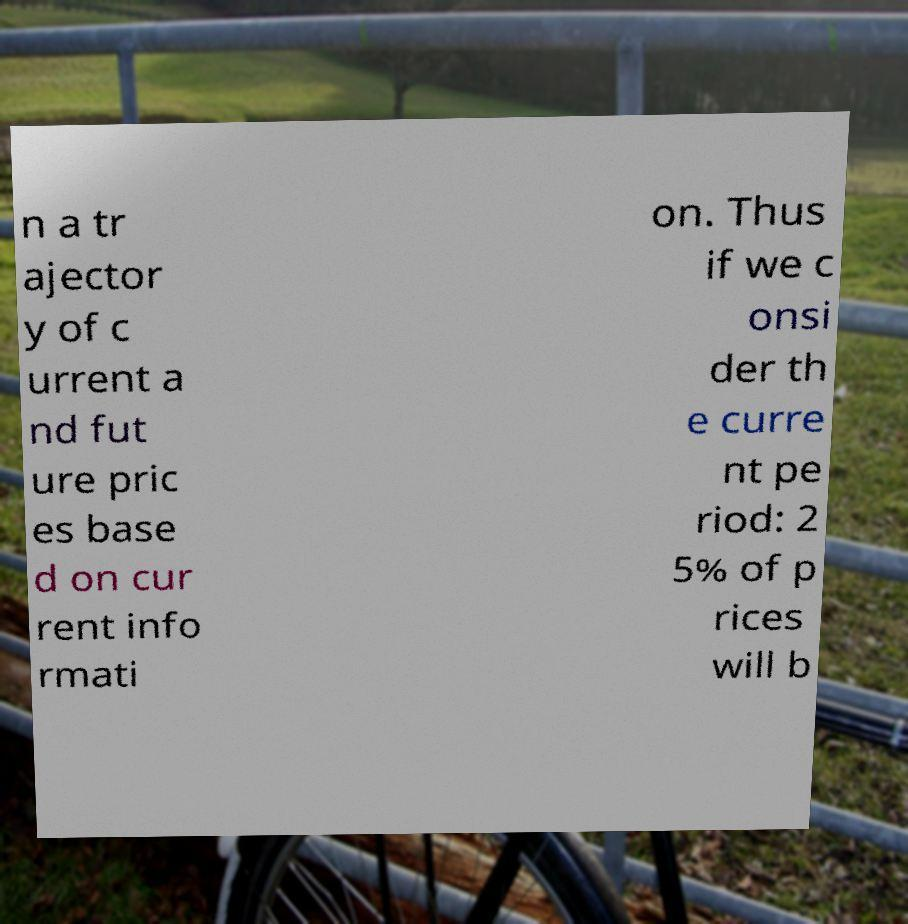Please read and relay the text visible in this image. What does it say? n a tr ajector y of c urrent a nd fut ure pric es base d on cur rent info rmati on. Thus if we c onsi der th e curre nt pe riod: 2 5% of p rices will b 